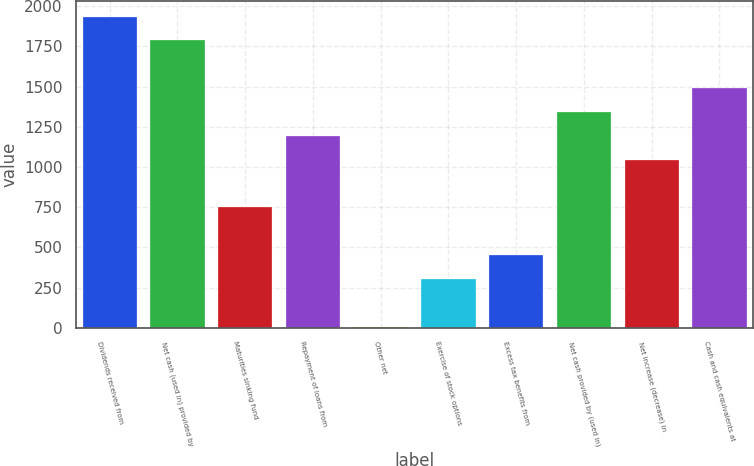Convert chart. <chart><loc_0><loc_0><loc_500><loc_500><bar_chart><fcel>Dividends received from<fcel>Net cash (used in) provided by<fcel>Maturities sinking fund<fcel>Repayment of loans from<fcel>Other net<fcel>Exercise of stock options<fcel>Excess tax benefits from<fcel>Net cash provided by (used in)<fcel>Net increase (decrease) in<fcel>Cash and cash equivalents at<nl><fcel>1936.5<fcel>1788<fcel>748.5<fcel>1194<fcel>6<fcel>303<fcel>451.5<fcel>1342.5<fcel>1045.5<fcel>1491<nl></chart> 